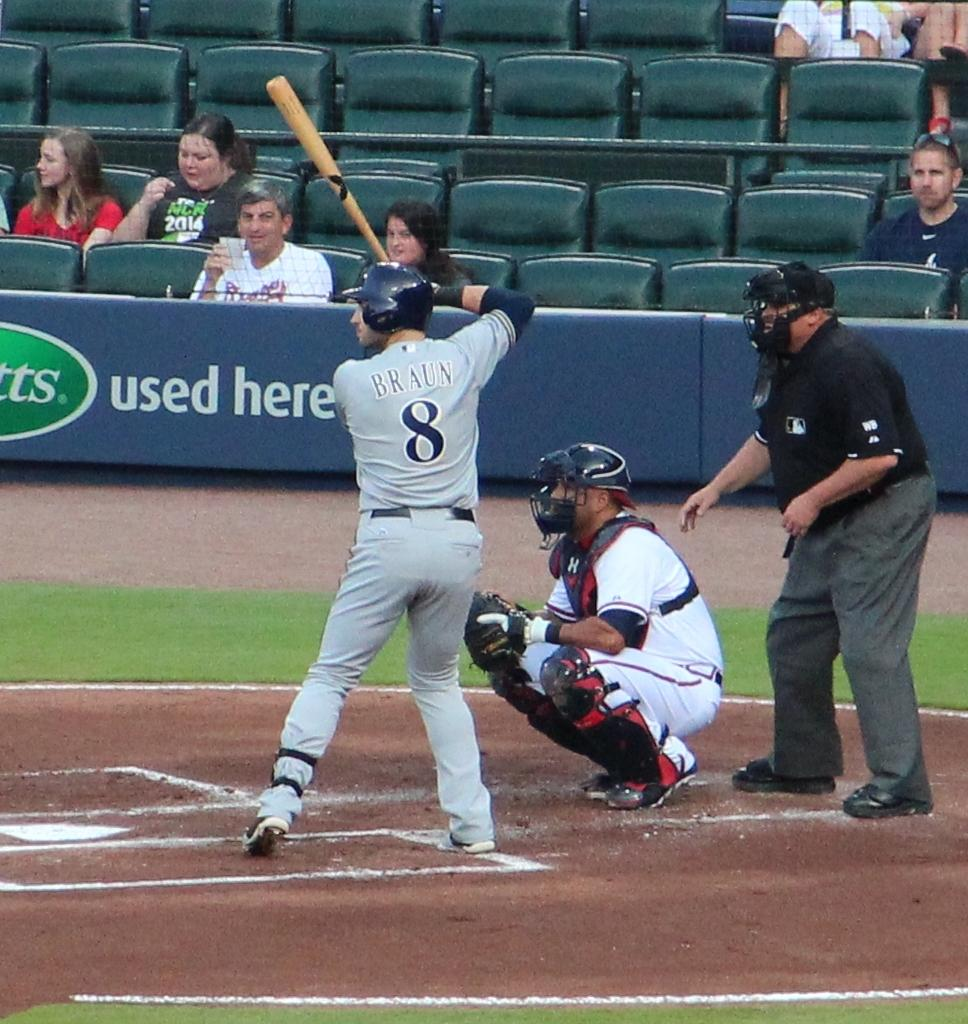<image>
Give a short and clear explanation of the subsequent image. Baseball player Braun prepares to swing and hit a pitch during a baseball game. 